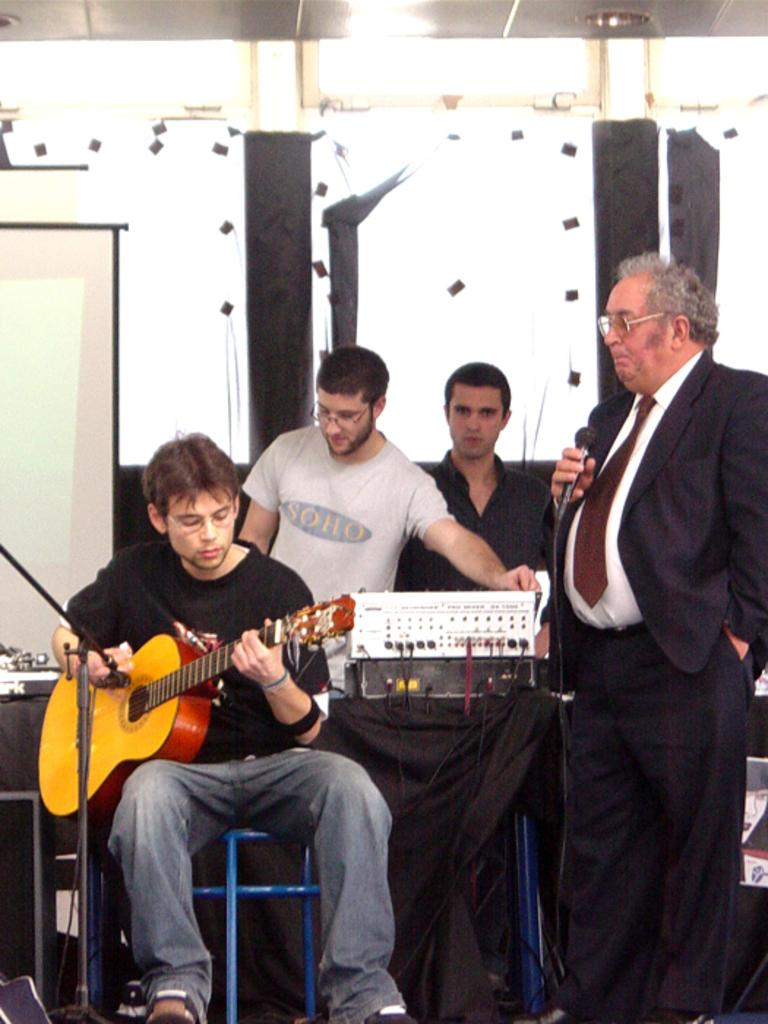What is the main subject of the image? The main subject of the image is a man sitting and playing the guitar. Are there any other people in the image? Yes, there are two men standing behind the guitar player and another man standing on the right side, holding a microphone. What is the man on the right side holding? The man on the right side is holding a microphone. Can you describe the attire of the man holding the microphone? The man holding the microphone is wearing a tie, shirt, and coat. How many chickens are visible in the image? There are no chickens present in the image. What type of celery is being used as a prop in the image? There is no celery present in the image. 